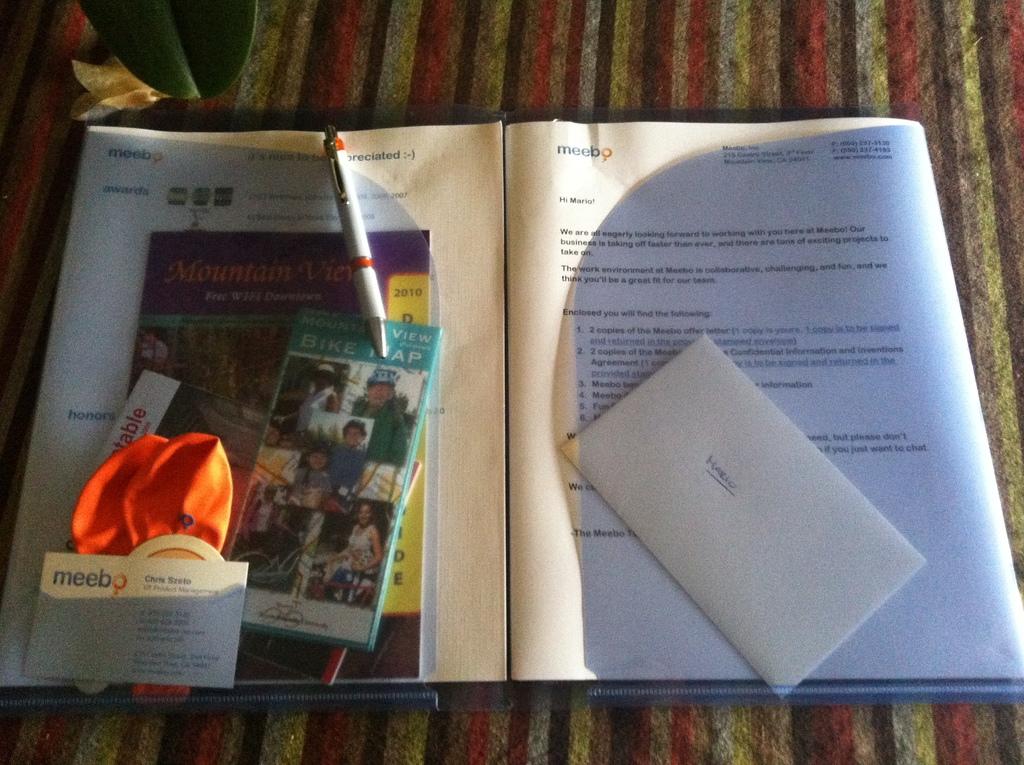Who's forst name is on the business card?
Ensure brevity in your answer.  Chris. 